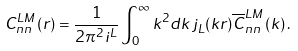Convert formula to latex. <formula><loc_0><loc_0><loc_500><loc_500>C _ { n n } ^ { L M } \left ( r \right ) = \frac { 1 } { 2 \pi ^ { 2 } i ^ { L } } \int _ { 0 } ^ { \infty } k ^ { 2 } d k \, j _ { L } ( k r ) \overline { C } _ { n n } ^ { L M } \left ( k \right ) .</formula> 